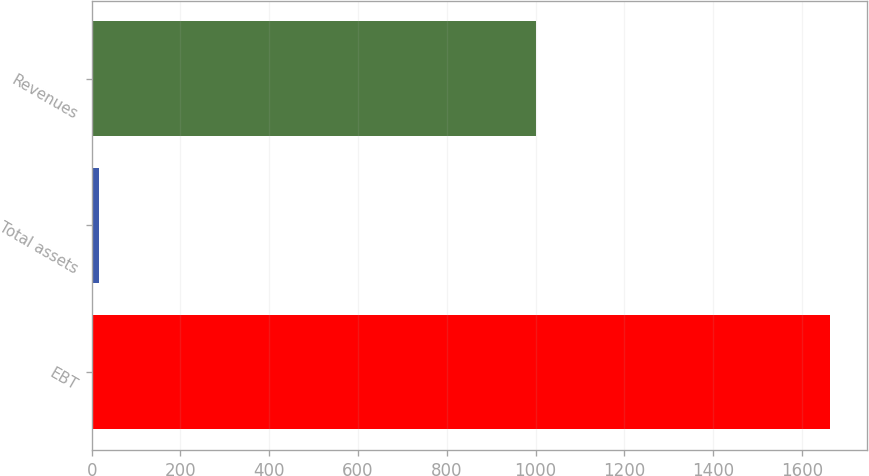<chart> <loc_0><loc_0><loc_500><loc_500><bar_chart><fcel>EBT<fcel>Total assets<fcel>Revenues<nl><fcel>1663<fcel>16<fcel>1000<nl></chart> 